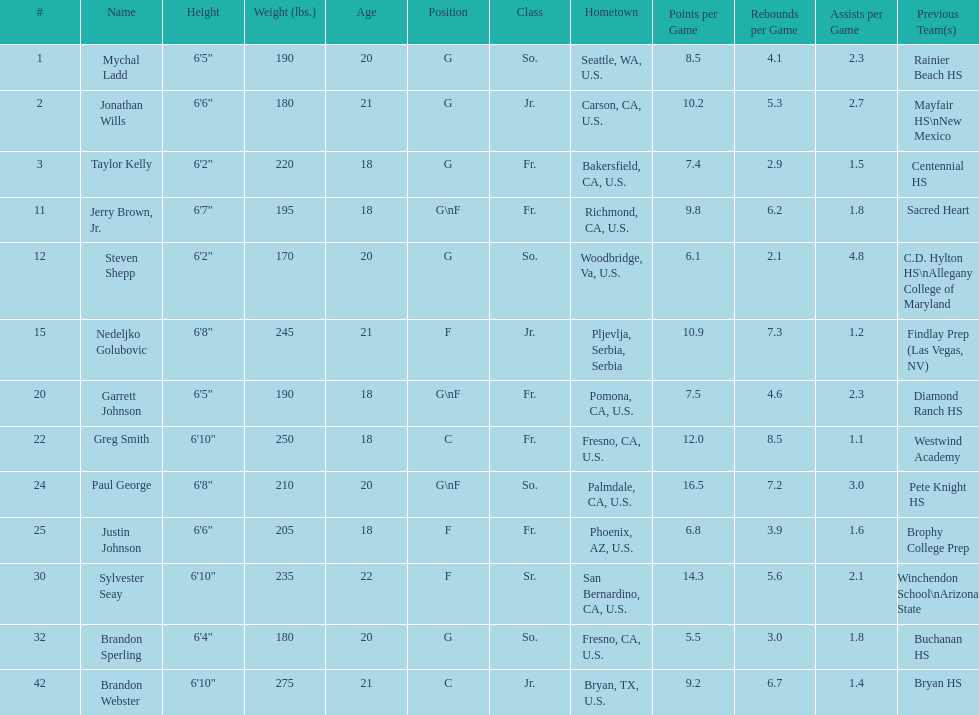Which player who is only a forward (f) is the shortest? Justin Johnson. 